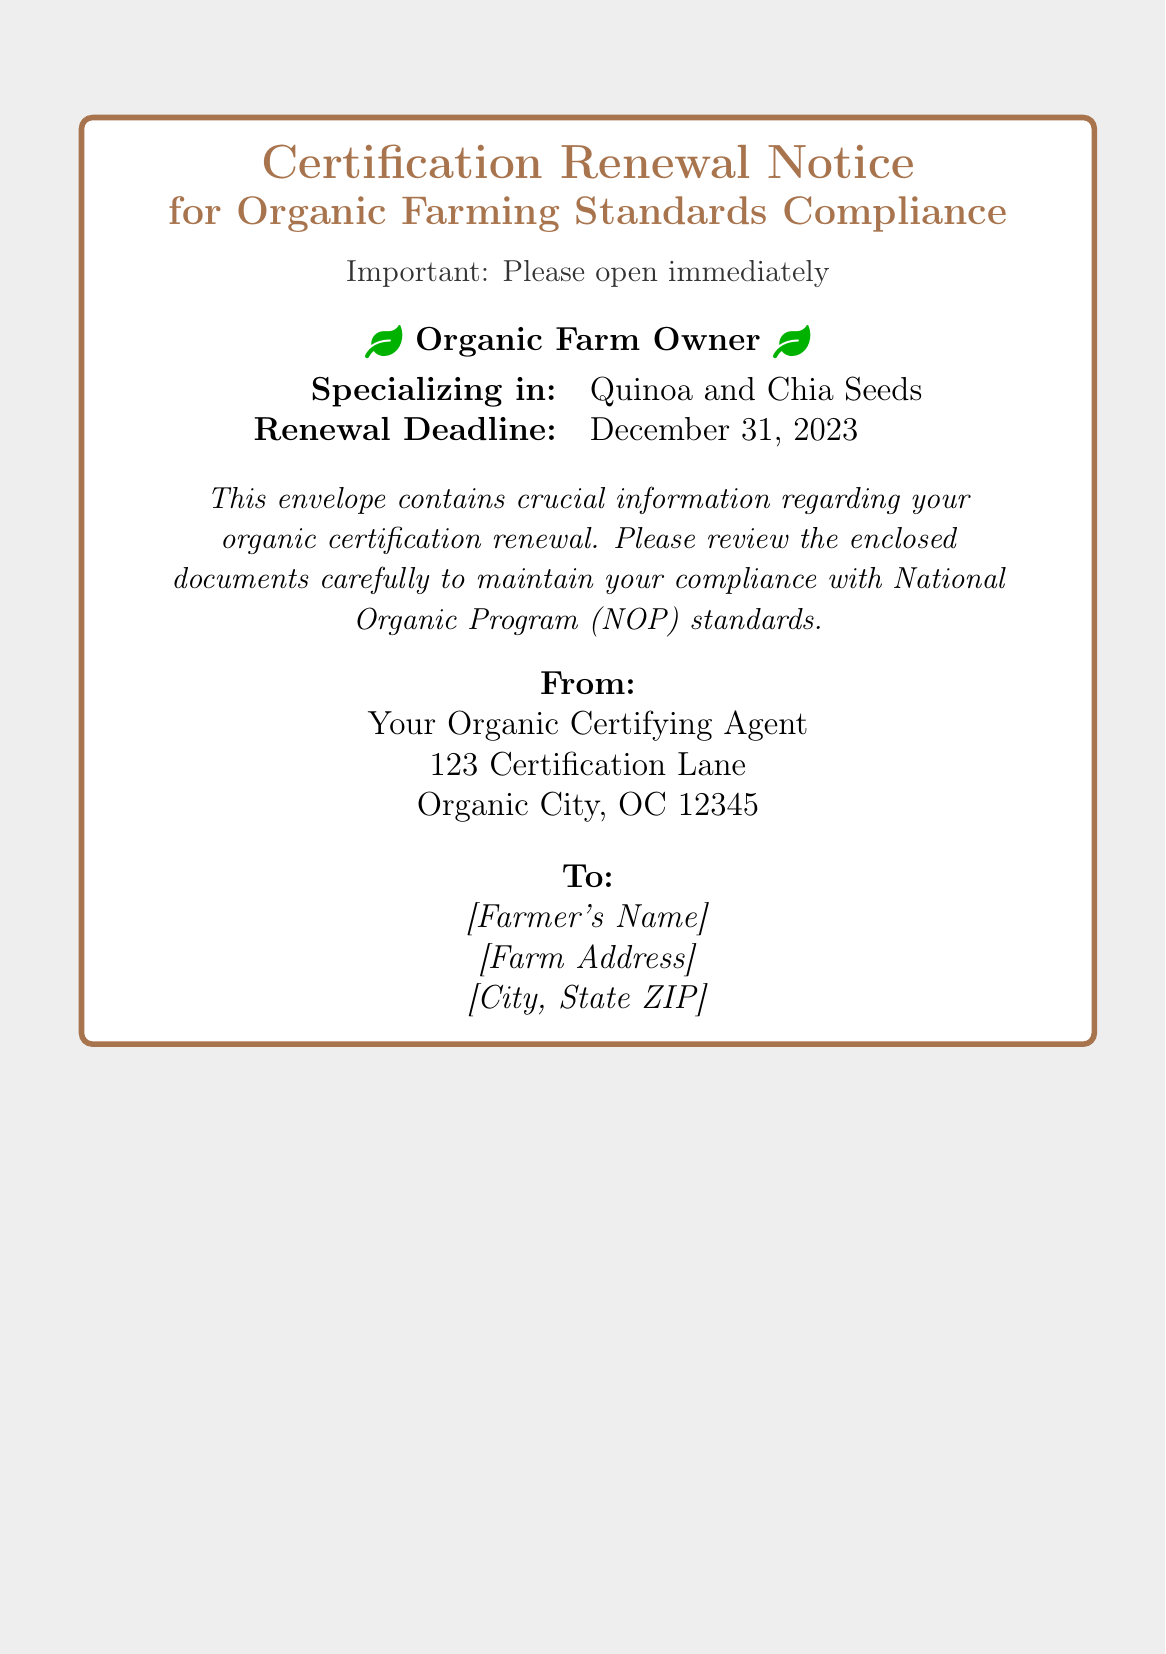What is the type of the document? The document is a certification renewal notice specifically related to organic farming standards compliance.
Answer: Certification Renewal Notice Who is the document addressed to? The document is addressed to the organic farm owner, with the placeholder indicating where their name would go.
Answer: [Farmer's Name] What is the specialization of the farm owner? The document states that the farm owner specializes in growing quinoa and chia seeds.
Answer: Quinoa and Chia Seeds What is the renewal deadline for certification? The deadline for renewal is specified in the document as December 31, 2023.
Answer: December 31, 2023 Who is the sender of the document? The sender is identified as the organic certifying agent from a specific address provided in the document.
Answer: Your Organic Certifying Agent What does the document encourage the recipient to do with the enclosed information? The document emphasizes the importance of reviewing the enclosed documents carefully to maintain compliance.
Answer: Review the enclosed documents carefully What color scheme is used in the document? The document features a color scheme using shades of brown and gray predominately.
Answer: Brown and gray What type of compliance does this notice pertain to? The notice is specifically related to compliance with National Organic Program (NOP) standards.
Answer: National Organic Program (NOP) standards 